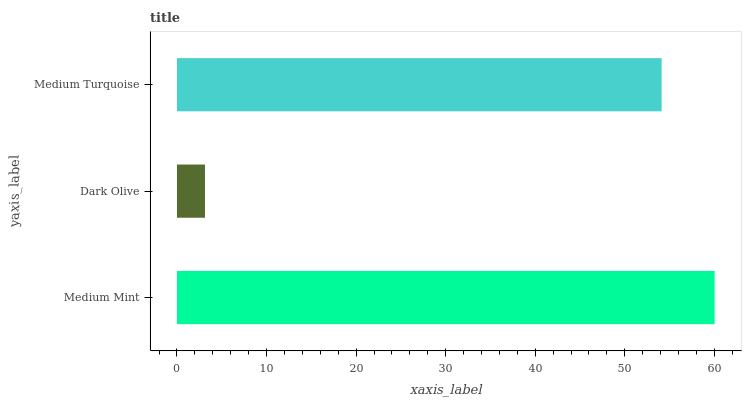Is Dark Olive the minimum?
Answer yes or no. Yes. Is Medium Mint the maximum?
Answer yes or no. Yes. Is Medium Turquoise the minimum?
Answer yes or no. No. Is Medium Turquoise the maximum?
Answer yes or no. No. Is Medium Turquoise greater than Dark Olive?
Answer yes or no. Yes. Is Dark Olive less than Medium Turquoise?
Answer yes or no. Yes. Is Dark Olive greater than Medium Turquoise?
Answer yes or no. No. Is Medium Turquoise less than Dark Olive?
Answer yes or no. No. Is Medium Turquoise the high median?
Answer yes or no. Yes. Is Medium Turquoise the low median?
Answer yes or no. Yes. Is Medium Mint the high median?
Answer yes or no. No. Is Medium Mint the low median?
Answer yes or no. No. 